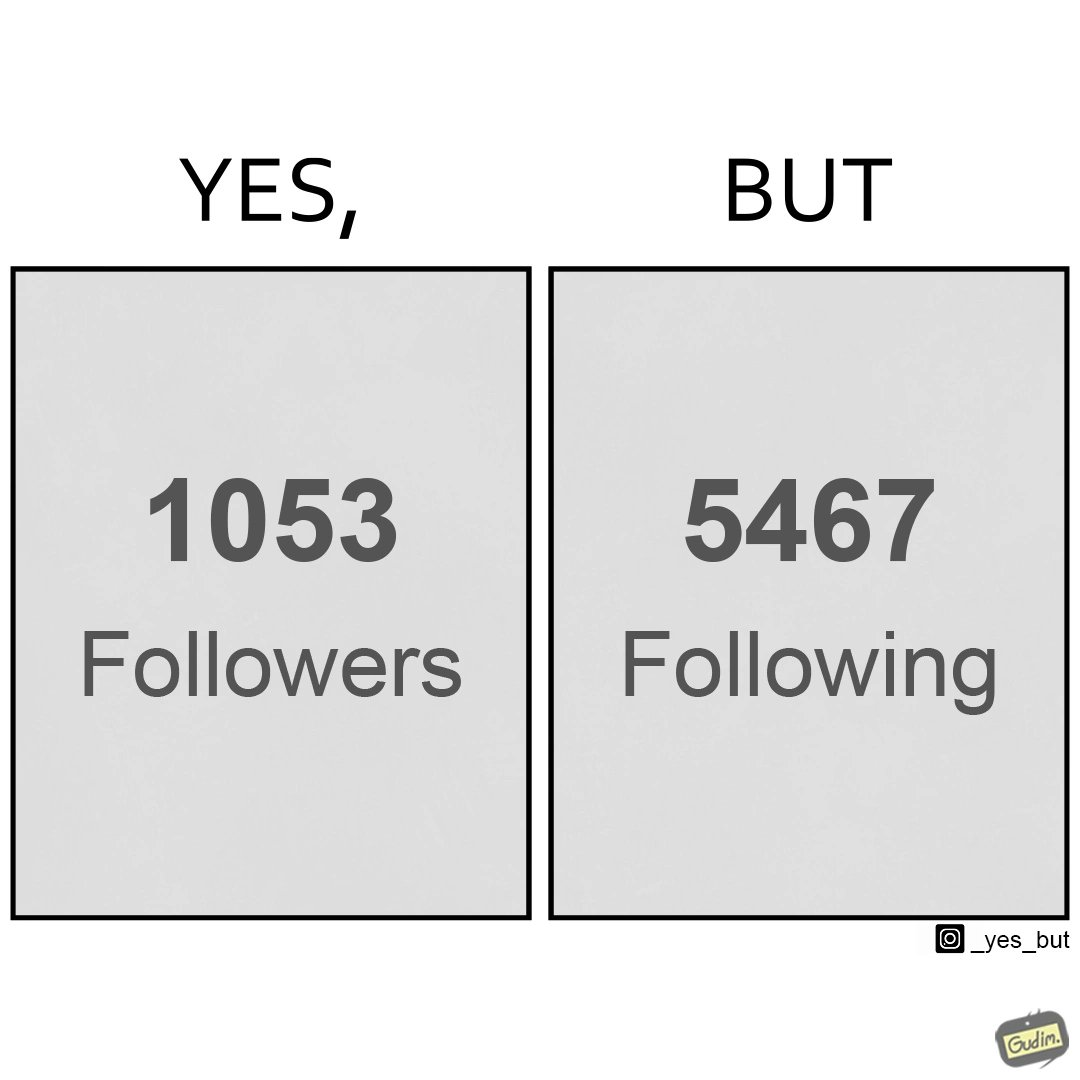Compare the left and right sides of this image. In the left part of the image: it shows the count of followers on a random social media account In the right part of the image: it shows the count of following on a random social media account 